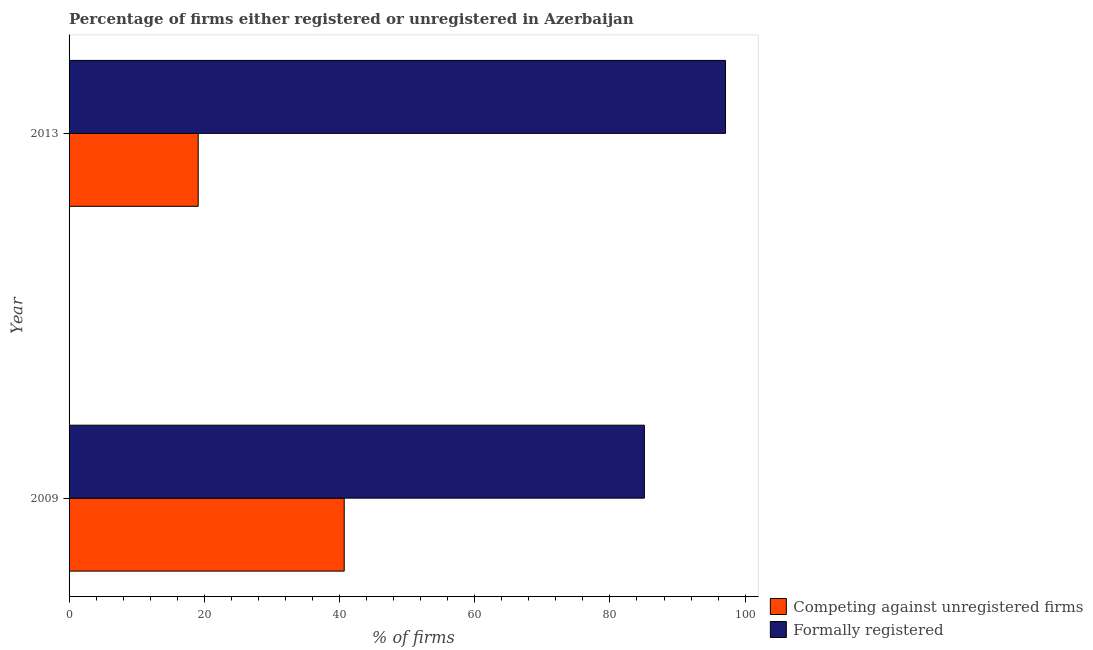How many different coloured bars are there?
Your answer should be very brief. 2. What is the label of the 2nd group of bars from the top?
Offer a very short reply. 2009. In how many cases, is the number of bars for a given year not equal to the number of legend labels?
Keep it short and to the point. 0. What is the percentage of registered firms in 2009?
Ensure brevity in your answer.  40.7. Across all years, what is the maximum percentage of formally registered firms?
Your answer should be compact. 97.1. Across all years, what is the minimum percentage of registered firms?
Keep it short and to the point. 19.1. In which year was the percentage of registered firms minimum?
Ensure brevity in your answer.  2013. What is the total percentage of registered firms in the graph?
Make the answer very short. 59.8. What is the difference between the percentage of registered firms in 2009 and that in 2013?
Make the answer very short. 21.6. What is the difference between the percentage of registered firms in 2009 and the percentage of formally registered firms in 2013?
Provide a short and direct response. -56.4. What is the average percentage of registered firms per year?
Your answer should be compact. 29.9. In how many years, is the percentage of registered firms greater than 72 %?
Your answer should be compact. 0. What is the ratio of the percentage of registered firms in 2009 to that in 2013?
Provide a short and direct response. 2.13. Is the difference between the percentage of formally registered firms in 2009 and 2013 greater than the difference between the percentage of registered firms in 2009 and 2013?
Ensure brevity in your answer.  No. What does the 1st bar from the top in 2009 represents?
Give a very brief answer. Formally registered. What does the 1st bar from the bottom in 2009 represents?
Your response must be concise. Competing against unregistered firms. How many years are there in the graph?
Your response must be concise. 2. What is the difference between two consecutive major ticks on the X-axis?
Your answer should be compact. 20. Does the graph contain any zero values?
Give a very brief answer. No. Does the graph contain grids?
Offer a very short reply. No. How many legend labels are there?
Provide a short and direct response. 2. How are the legend labels stacked?
Ensure brevity in your answer.  Vertical. What is the title of the graph?
Provide a succinct answer. Percentage of firms either registered or unregistered in Azerbaijan. What is the label or title of the X-axis?
Ensure brevity in your answer.  % of firms. What is the % of firms in Competing against unregistered firms in 2009?
Give a very brief answer. 40.7. What is the % of firms in Formally registered in 2009?
Offer a very short reply. 85.1. What is the % of firms of Competing against unregistered firms in 2013?
Provide a succinct answer. 19.1. What is the % of firms in Formally registered in 2013?
Your response must be concise. 97.1. Across all years, what is the maximum % of firms of Competing against unregistered firms?
Ensure brevity in your answer.  40.7. Across all years, what is the maximum % of firms of Formally registered?
Your answer should be very brief. 97.1. Across all years, what is the minimum % of firms of Competing against unregistered firms?
Ensure brevity in your answer.  19.1. Across all years, what is the minimum % of firms in Formally registered?
Provide a succinct answer. 85.1. What is the total % of firms of Competing against unregistered firms in the graph?
Offer a very short reply. 59.8. What is the total % of firms in Formally registered in the graph?
Your response must be concise. 182.2. What is the difference between the % of firms of Competing against unregistered firms in 2009 and that in 2013?
Your answer should be very brief. 21.6. What is the difference between the % of firms of Formally registered in 2009 and that in 2013?
Provide a succinct answer. -12. What is the difference between the % of firms in Competing against unregistered firms in 2009 and the % of firms in Formally registered in 2013?
Keep it short and to the point. -56.4. What is the average % of firms in Competing against unregistered firms per year?
Make the answer very short. 29.9. What is the average % of firms in Formally registered per year?
Make the answer very short. 91.1. In the year 2009, what is the difference between the % of firms of Competing against unregistered firms and % of firms of Formally registered?
Provide a succinct answer. -44.4. In the year 2013, what is the difference between the % of firms in Competing against unregistered firms and % of firms in Formally registered?
Keep it short and to the point. -78. What is the ratio of the % of firms in Competing against unregistered firms in 2009 to that in 2013?
Your answer should be very brief. 2.13. What is the ratio of the % of firms in Formally registered in 2009 to that in 2013?
Your answer should be very brief. 0.88. What is the difference between the highest and the second highest % of firms of Competing against unregistered firms?
Provide a succinct answer. 21.6. What is the difference between the highest and the second highest % of firms in Formally registered?
Make the answer very short. 12. What is the difference between the highest and the lowest % of firms of Competing against unregistered firms?
Keep it short and to the point. 21.6. 